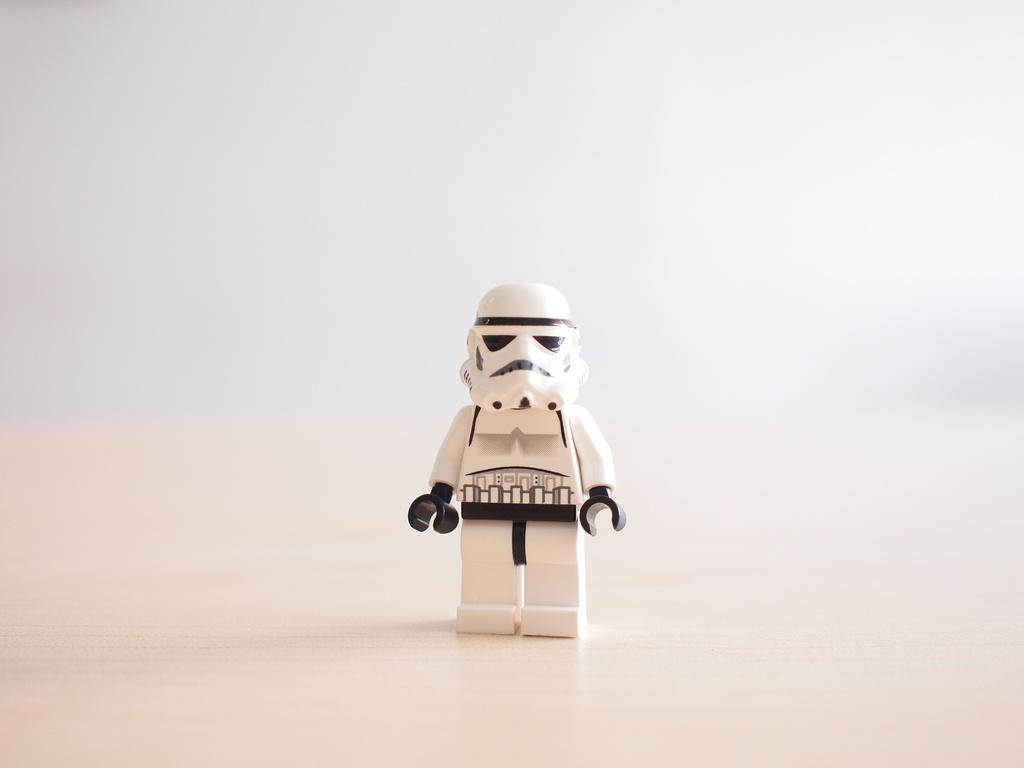What object can be seen in the image? There is a toy in the image. Where is the toy located? The toy is on a surface. What color is the background of the image? The background of the image is white. What type of trail can be seen in the image? There is no trail present in the image; it features a toy on a surface with a white background. 